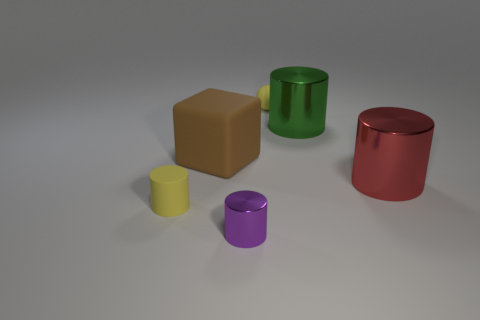Add 1 metallic things. How many objects exist? 7 Subtract all balls. How many objects are left? 5 Add 2 cylinders. How many cylinders are left? 6 Add 4 matte balls. How many matte balls exist? 5 Subtract 0 gray spheres. How many objects are left? 6 Subtract all tiny yellow spheres. Subtract all big shiny things. How many objects are left? 3 